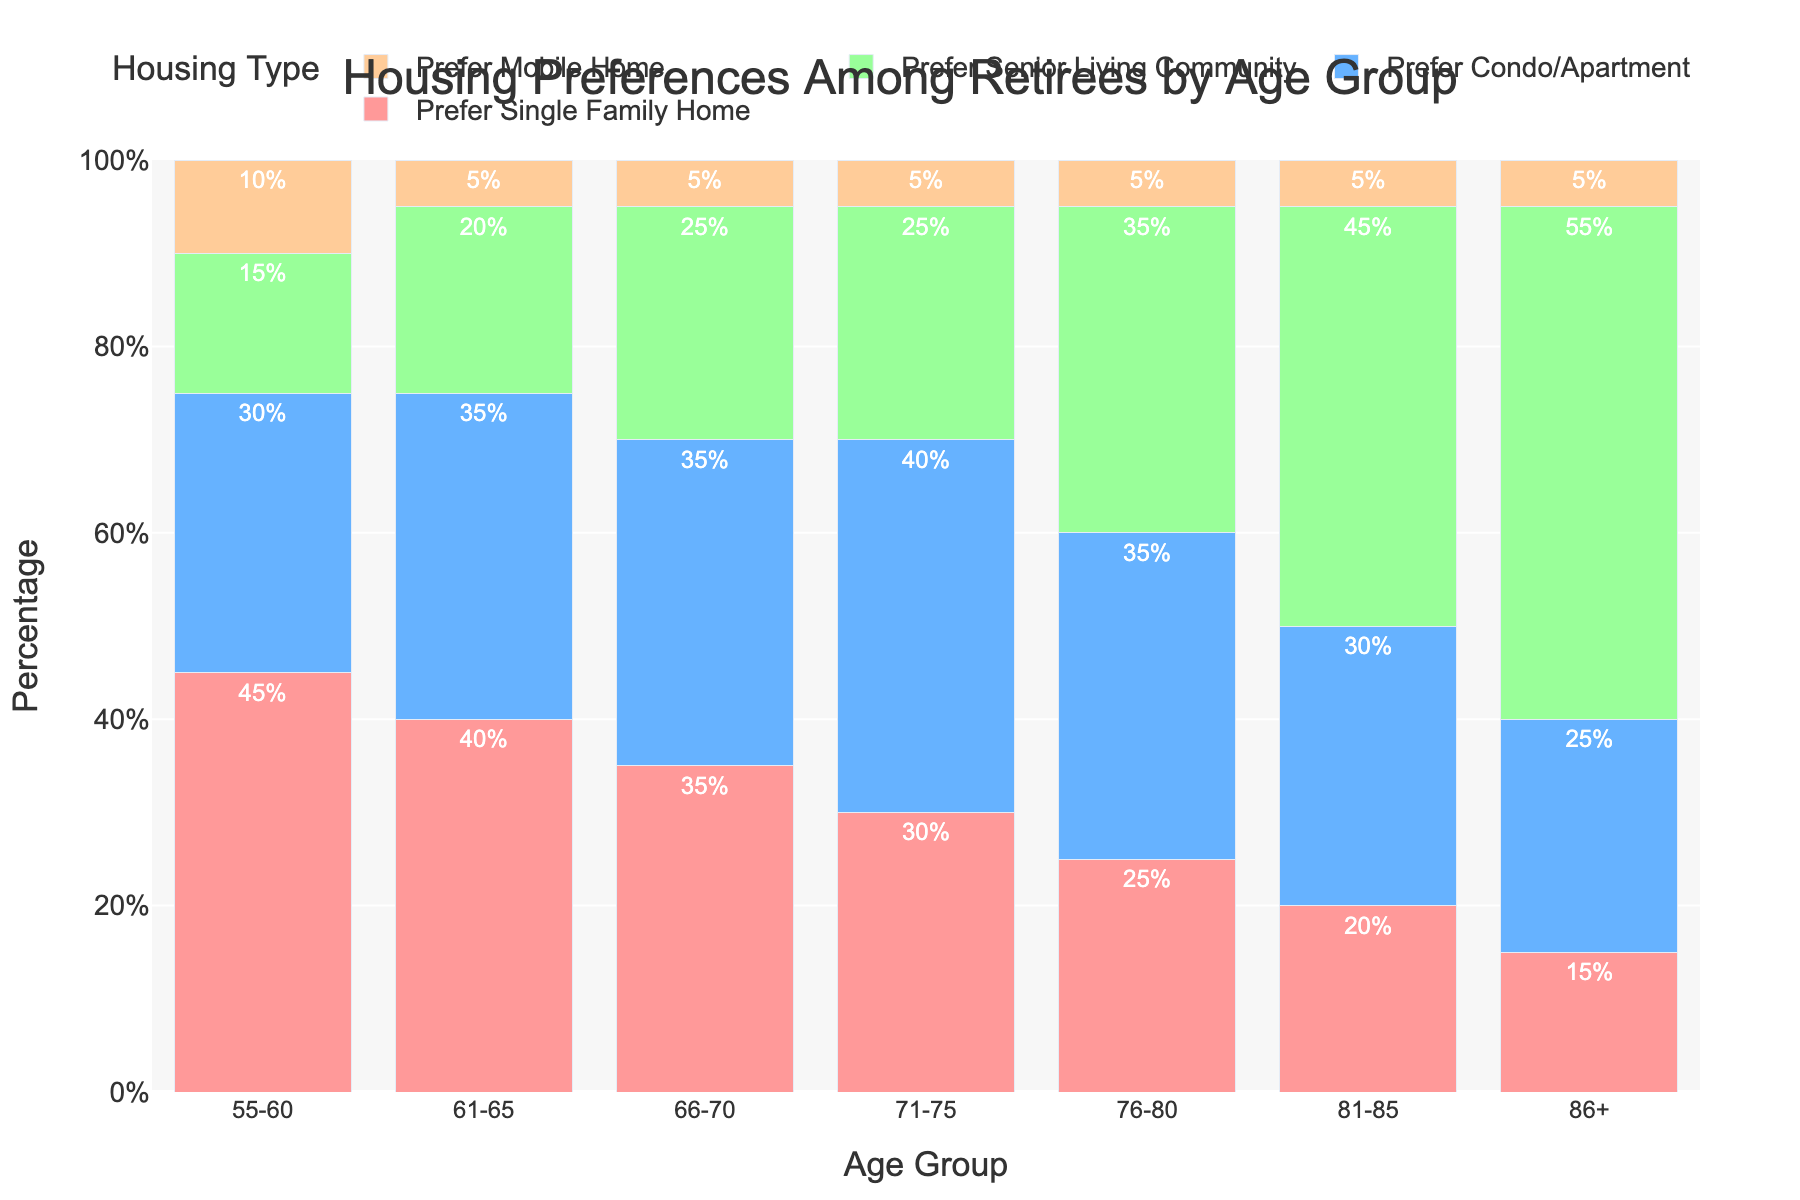What is the most preferred housing type among retirees aged 55-60? By observing the bars for the age group 55-60, we see the tallest bar is for "Prefer Single Family Home" at 45%. This is the highest value for this age group.
Answer: Prefer Single Family Home Which age group has the highest preference for Senior Living Community? By examining the heights of the "Senior Living Community" bars for all age groups, we see that the age group 86+ has the highest preference at 55%.
Answer: 86+ In which age group is the preference for Condos/Apartments and Mobile Homes equal? By examining the bars for each age group, we see that the age group 66-70 has a preference of 35% for both Condos/Apartments and Mobile Homes.
Answer: 66-70 What is the total percentage of retirees aged 81-85 who prefer single family homes or condos/apartments? Sum the values of retirees aged 81-85 who prefer single family homes (20%) and condos/apartments (30%). The total is 20% + 30% = 50%.
Answer: 50% Compare the preference for Single Family Home and Senior Living Community for retirees aged 71-75. Which one is higher, and what is the difference? From the chart, preferences for Single Family Home and Senior Living Community for 71-75 are 30% and 25%. Single Family Home is higher, and the difference is 30% - 25% = 5%.
Answer: Single Family Home by 5% What is the average preference for Mobile Homes across all age groups? Add preferences for Mobile Homes for all age groups and divide by the number of age groups. (10% + 5% + 5% + 5% + 5% + 5% + 5%) / 7 = 40% / 7 ≈ 5.71%.
Answer: ≈ 5.71% Which housing type consistently remains within 5%-10% preference across all age groups? Observing the bars, Mobile Homes consistently have a preference within 5%-10% across all age groups.
Answer: Mobile Homes For the age group 76-80, which housing type shows the highest increase compared to the previous age group 71-75? Compare the preferences for 71-75 and 76-80. The Senior Living Community increases from 25% to 35%, which is the highest increase of 10%.
Answer: Senior Living Community by 10% Between the age groups 55-60 and 81-85, which housing type sees the most significant decrease in preference? Observing the bars for both age groups, "Single Family Home" decreases from 45% in 55-60 to 20% in 81-85. This is the most significant decrease of 25%.
Answer: Single Family Home by 25% What is the combined percentage preference for all housing types among retirees aged 61-65? Sum the percentage preferences for all housing types for the age group 61-65: 40% (Single Family Home) + 35% (Condo/Apartment) + 20% (Senior Living Community) + 5% (Mobile Home) = 100%.
Answer: 100% 